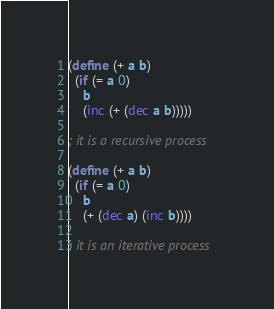Convert code to text. <code><loc_0><loc_0><loc_500><loc_500><_Scheme_>(define (+ a b)
  (if (= a 0)
    b
    (inc (+ (dec a b)))))

; it is a recursive process

(define (+ a b)
  (if (= a 0)
    b
    (+ (dec a) (inc b))))

; it is an iterative process
</code> 